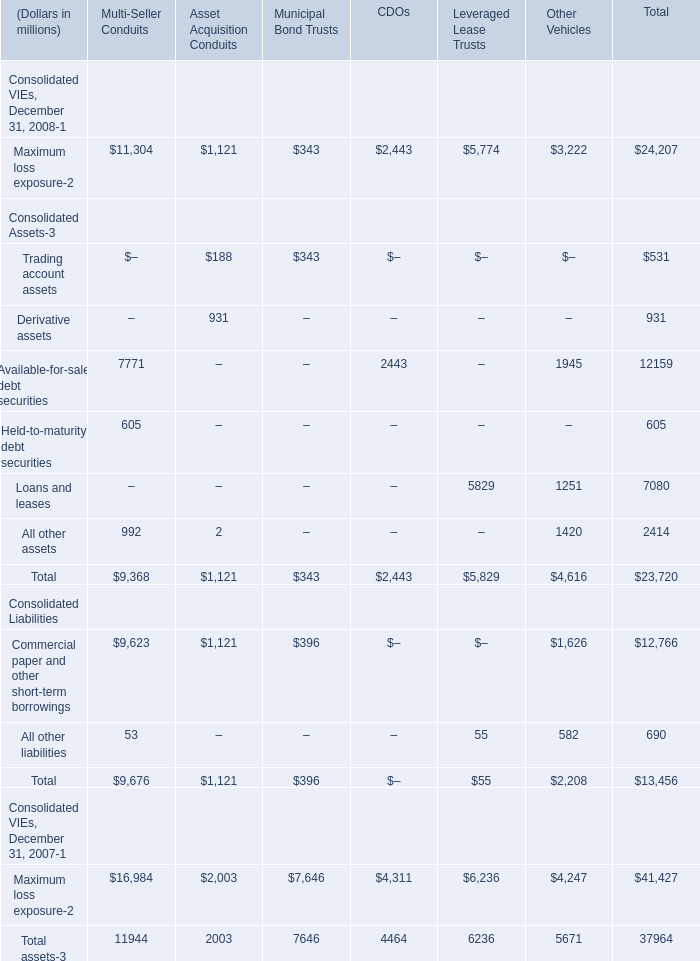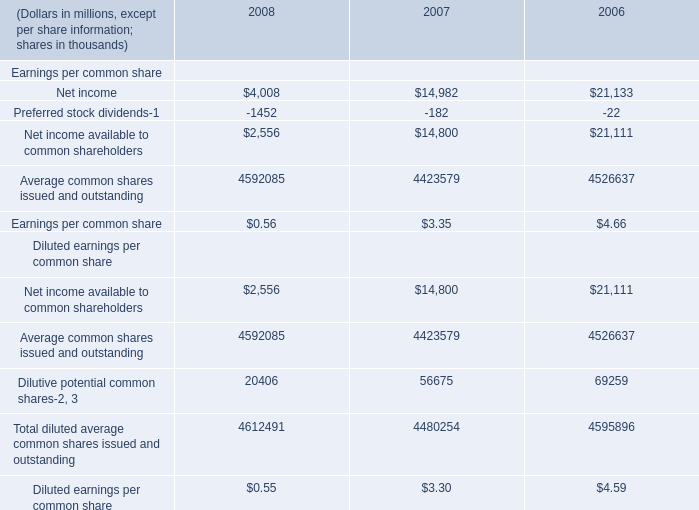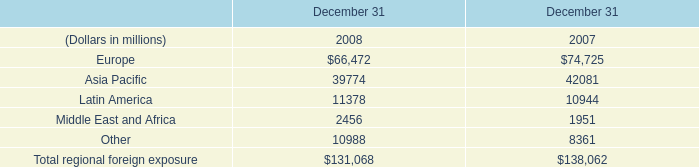What's the average of Net income of 2008, and Maximum loss exposure Consolidated VIEs, December 31, 2007 of CDOs ? 
Computations: ((4008.0 + 4311.0) / 2)
Answer: 4159.5. 